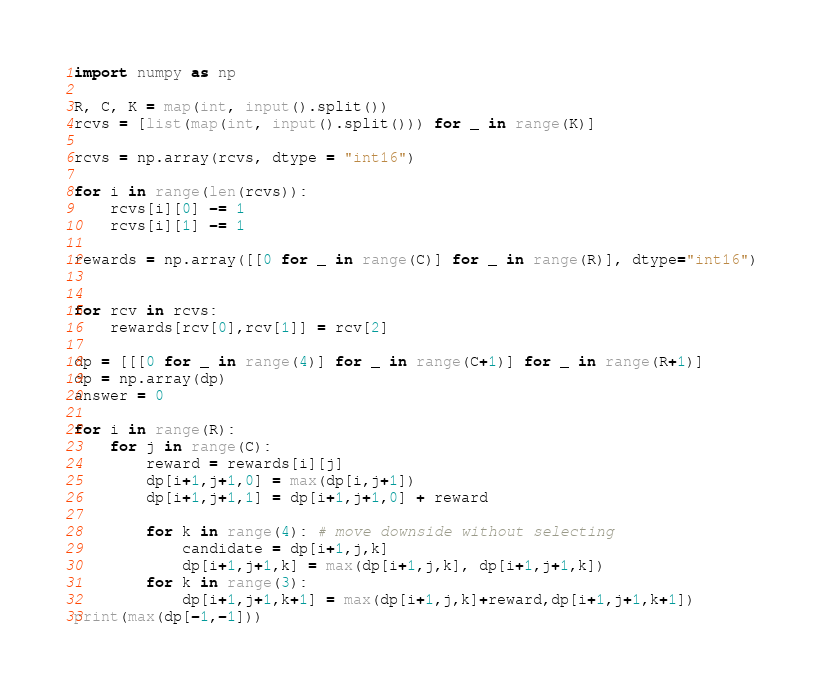<code> <loc_0><loc_0><loc_500><loc_500><_Python_>import numpy as np

R, C, K = map(int, input().split())
rcvs = [list(map(int, input().split())) for _ in range(K)]

rcvs = np.array(rcvs, dtype = "int16")

for i in range(len(rcvs)):
    rcvs[i][0] -= 1
    rcvs[i][1] -= 1

rewards = np.array([[0 for _ in range(C)] for _ in range(R)], dtype="int16")


for rcv in rcvs:
    rewards[rcv[0],rcv[1]] = rcv[2]

dp = [[[0 for _ in range(4)] for _ in range(C+1)] for _ in range(R+1)]
dp = np.array(dp)
answer = 0

for i in range(R):
    for j in range(C):
        reward = rewards[i][j]
        dp[i+1,j+1,0] = max(dp[i,j+1])
        dp[i+1,j+1,1] = dp[i+1,j+1,0] + reward
        
        for k in range(4): # move downside without selecting
            candidate = dp[i+1,j,k]
            dp[i+1,j+1,k] = max(dp[i+1,j,k], dp[i+1,j+1,k])
        for k in range(3):
            dp[i+1,j+1,k+1] = max(dp[i+1,j,k]+reward,dp[i+1,j+1,k+1])
print(max(dp[-1,-1]))</code> 